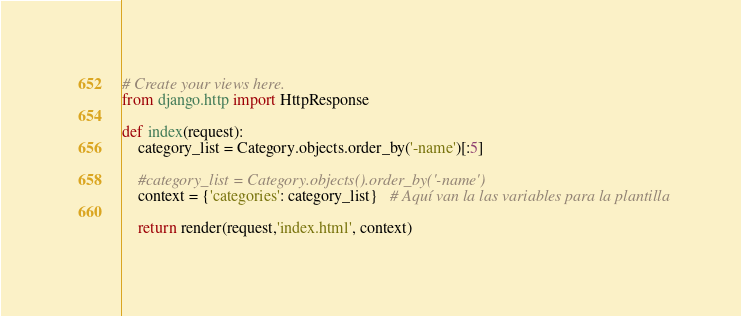<code> <loc_0><loc_0><loc_500><loc_500><_Python_># Create your views here.
from django.http import HttpResponse

def index(request):
    category_list = Category.objects.order_by('-name')[:5]

    #category_list = Category.objects().order_by('-name')
    context = {'categories': category_list}   # Aquí van la las variables para la plantilla

    return render(request,'index.html', context)
</code> 